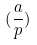<formula> <loc_0><loc_0><loc_500><loc_500>( \frac { a } { p } )</formula> 